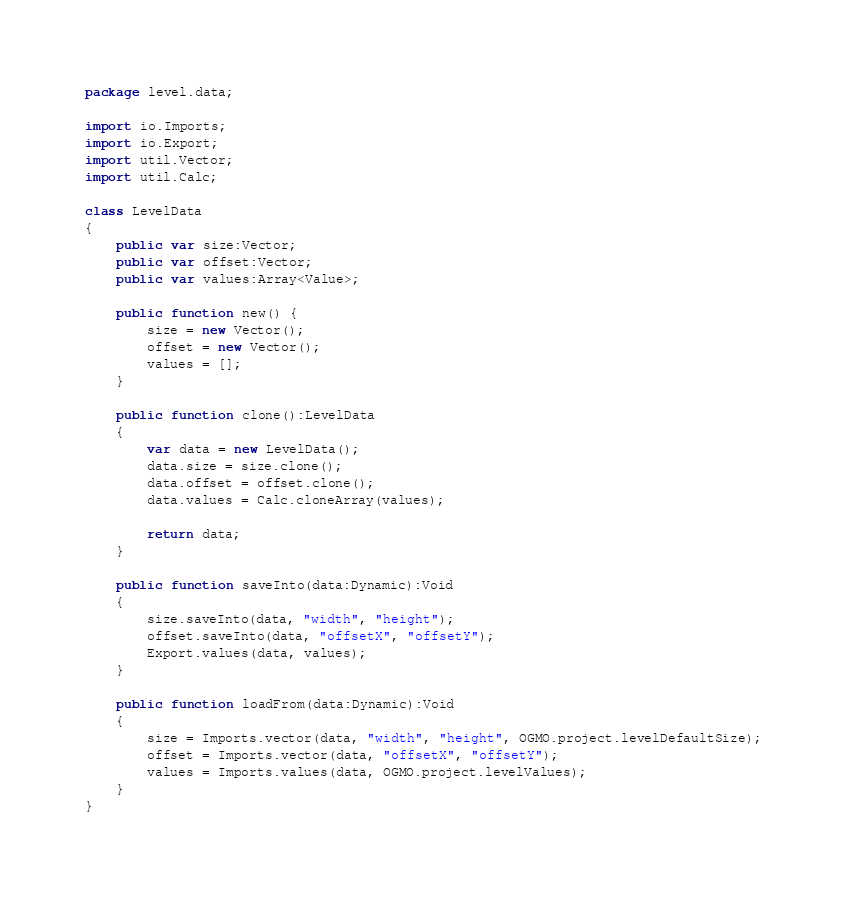<code> <loc_0><loc_0><loc_500><loc_500><_Haxe_>package level.data;

import io.Imports;
import io.Export;
import util.Vector;
import util.Calc;

class LevelData
{
	public var size:Vector;
	public var offset:Vector;
	public var values:Array<Value>;

	public function new() {
		size = new Vector();
		offset = new Vector();
		values = [];
	}

	public function clone():LevelData
	{
		var data = new LevelData();
		data.size = size.clone();
		data.offset = offset.clone();
		data.values = Calc.cloneArray(values);

		return data;
	}

	public function saveInto(data:Dynamic):Void
	{
		size.saveInto(data, "width", "height");
		offset.saveInto(data, "offsetX", "offsetY");
		Export.values(data, values);
	}

	public function loadFrom(data:Dynamic):Void
	{
		size = Imports.vector(data, "width", "height", OGMO.project.levelDefaultSize);
		offset = Imports.vector(data, "offsetX", "offsetY");
		values = Imports.values(data, OGMO.project.levelValues);
	}
}</code> 